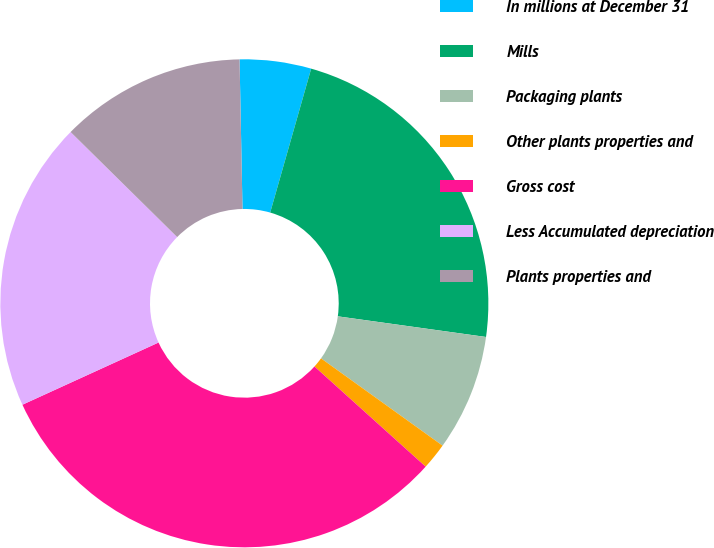Convert chart to OTSL. <chart><loc_0><loc_0><loc_500><loc_500><pie_chart><fcel>In millions at December 31<fcel>Mills<fcel>Packaging plants<fcel>Other plants properties and<fcel>Gross cost<fcel>Less Accumulated depreciation<fcel>Plants properties and<nl><fcel>4.73%<fcel>22.79%<fcel>7.71%<fcel>1.76%<fcel>31.51%<fcel>19.21%<fcel>12.3%<nl></chart> 